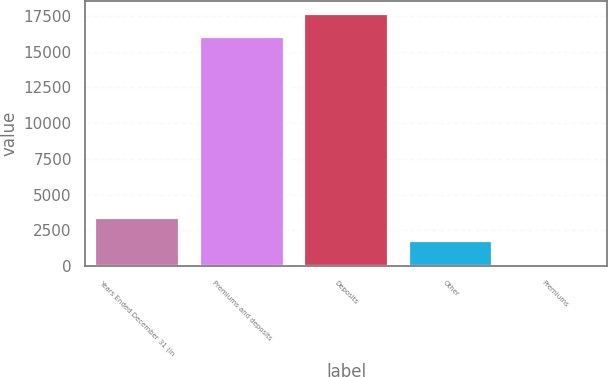Convert chart to OTSL. <chart><loc_0><loc_0><loc_500><loc_500><bar_chart><fcel>Years Ended December 31 (in<fcel>Premiums and deposits<fcel>Deposits<fcel>Other<fcel>Premiums<nl><fcel>3336.6<fcel>16048<fcel>17656.3<fcel>1728.3<fcel>120<nl></chart> 